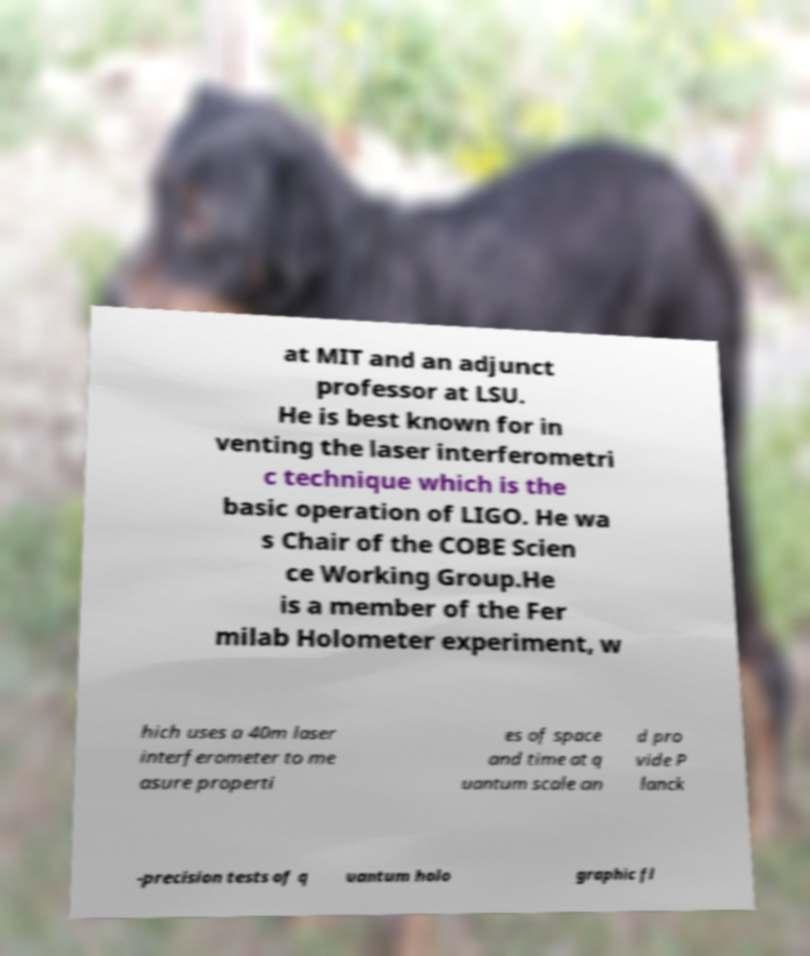I need the written content from this picture converted into text. Can you do that? at MIT and an adjunct professor at LSU. He is best known for in venting the laser interferometri c technique which is the basic operation of LIGO. He wa s Chair of the COBE Scien ce Working Group.He is a member of the Fer milab Holometer experiment, w hich uses a 40m laser interferometer to me asure properti es of space and time at q uantum scale an d pro vide P lanck -precision tests of q uantum holo graphic fl 